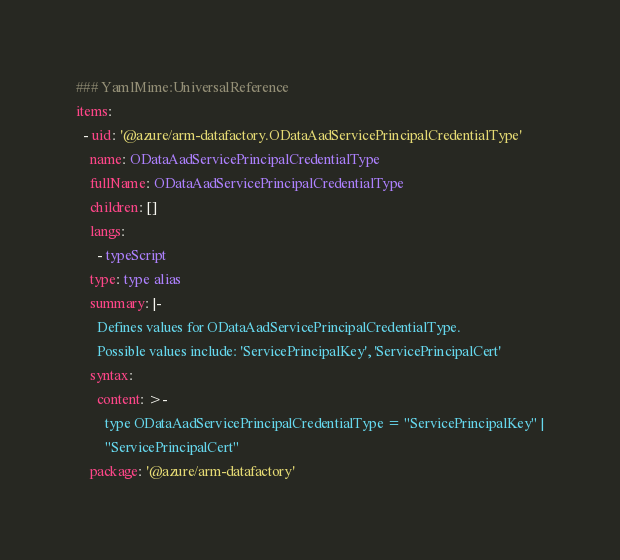Convert code to text. <code><loc_0><loc_0><loc_500><loc_500><_YAML_>### YamlMime:UniversalReference
items:
  - uid: '@azure/arm-datafactory.ODataAadServicePrincipalCredentialType'
    name: ODataAadServicePrincipalCredentialType
    fullName: ODataAadServicePrincipalCredentialType
    children: []
    langs:
      - typeScript
    type: type alias
    summary: |-
      Defines values for ODataAadServicePrincipalCredentialType.
      Possible values include: 'ServicePrincipalKey', 'ServicePrincipalCert'
    syntax:
      content: >-
        type ODataAadServicePrincipalCredentialType = "ServicePrincipalKey" |
        "ServicePrincipalCert"
    package: '@azure/arm-datafactory'
</code> 